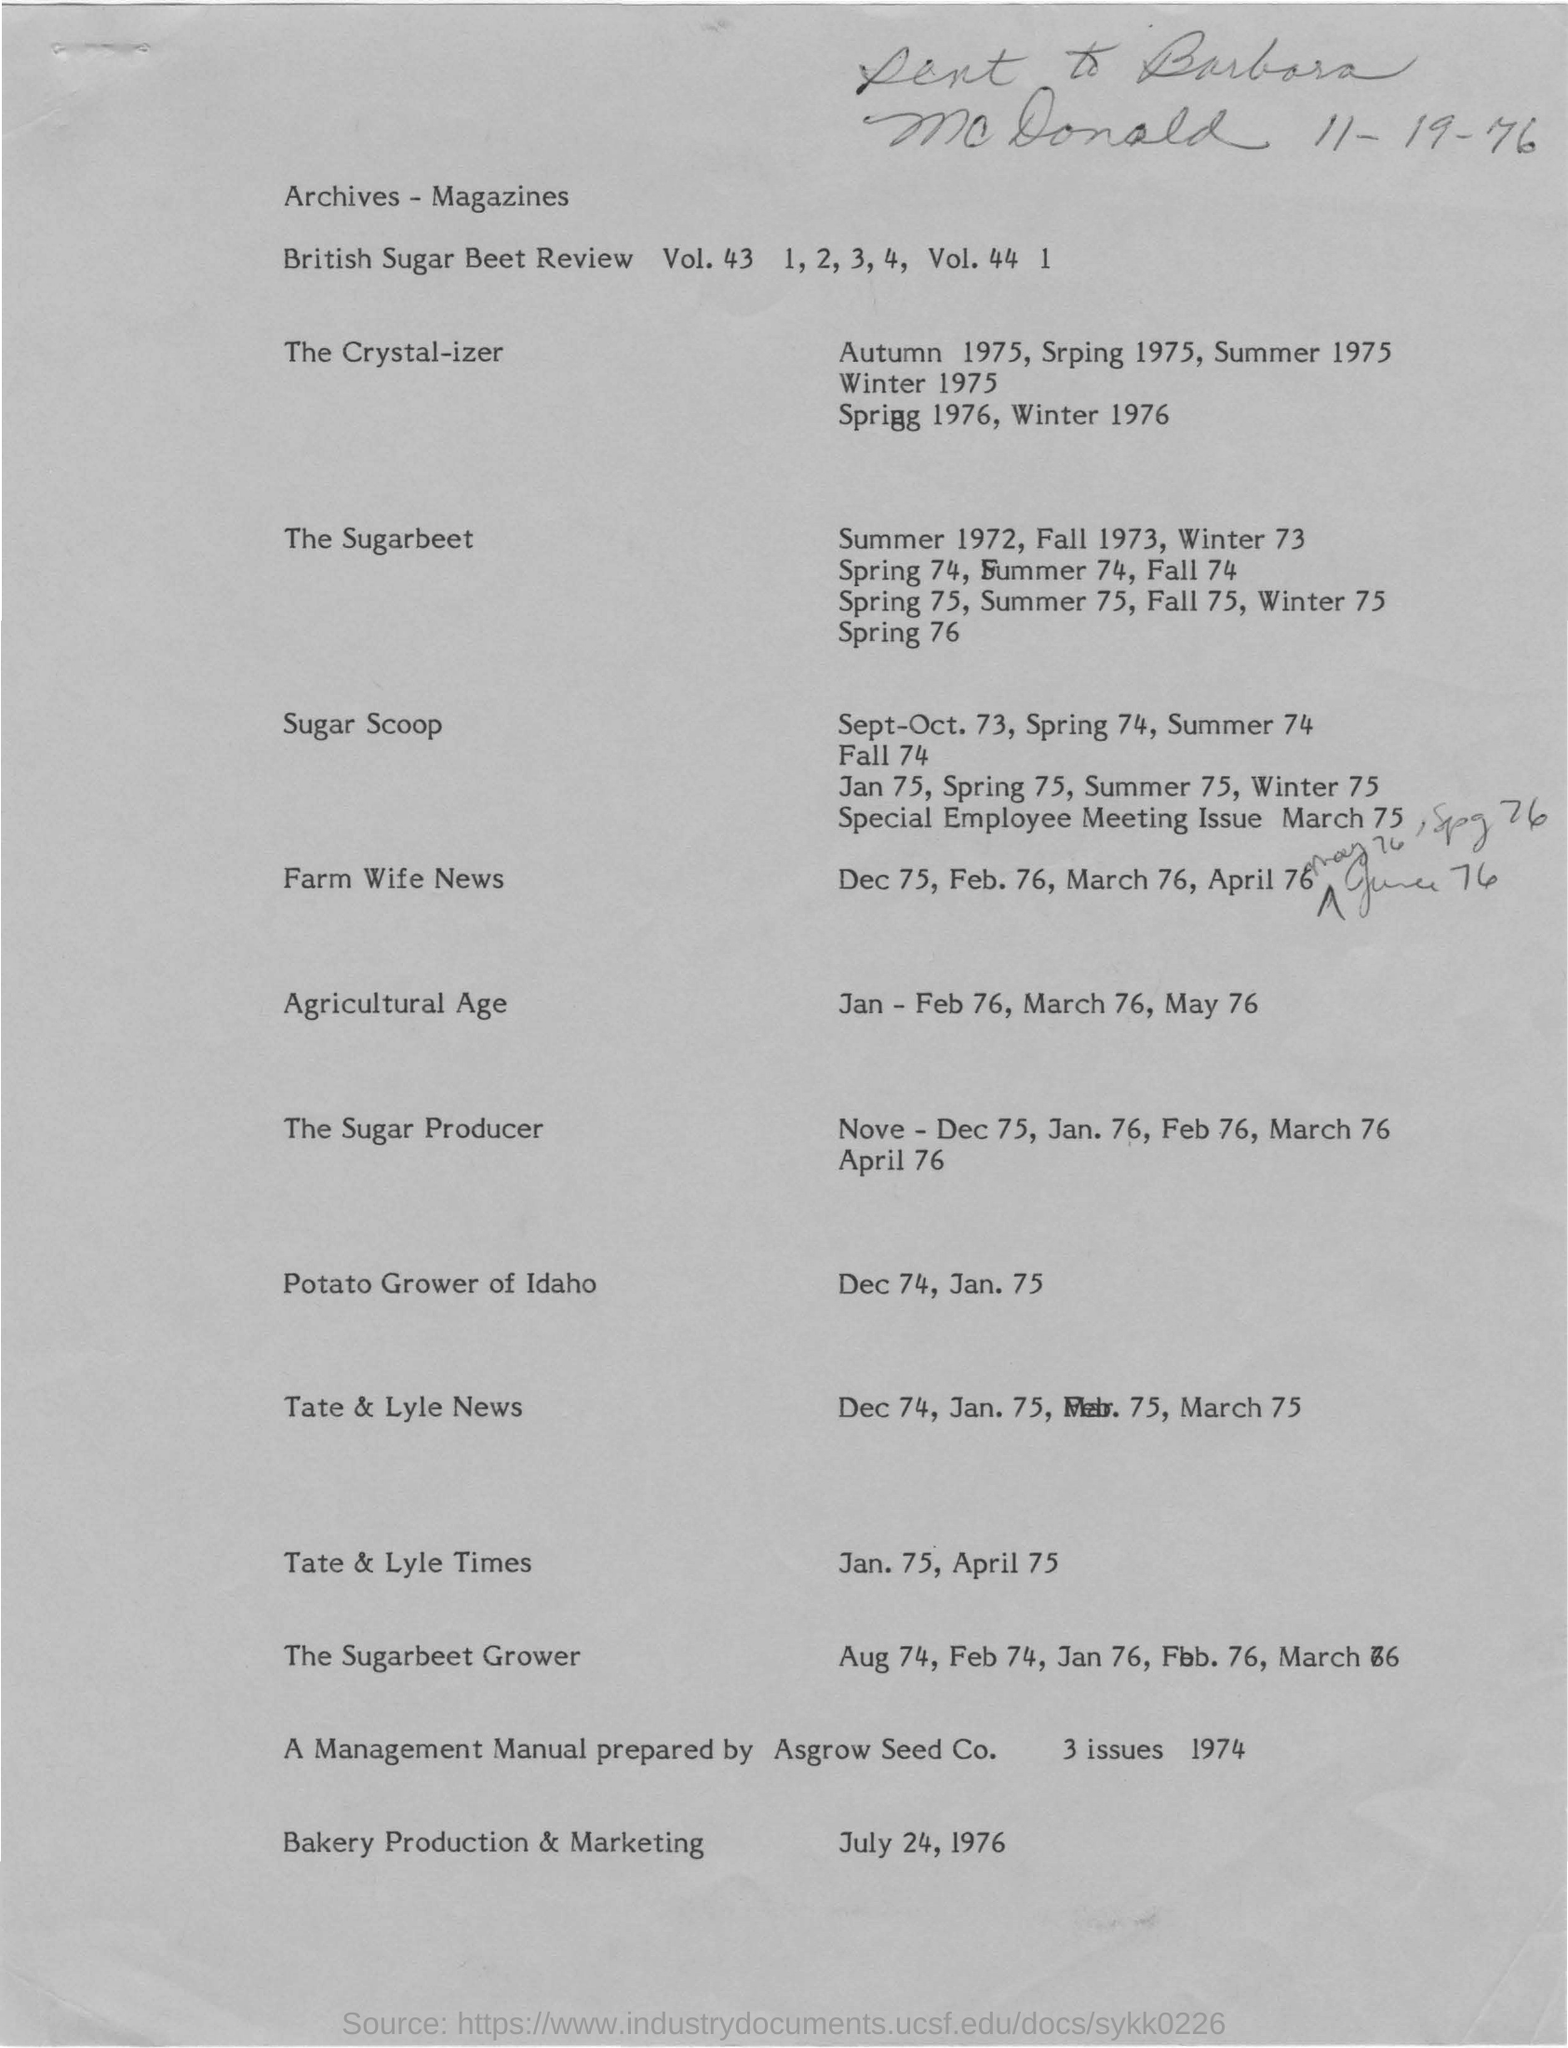Indicate a few pertinent items in this graphic. The Agricultural Age was mentioned in the document during the period of January and February 1976, March 1976, and May 1976. The date at the top of the document is November 19, 1976. 